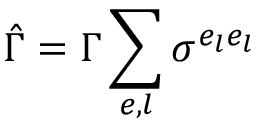<formula> <loc_0><loc_0><loc_500><loc_500>\hat { \Gamma } = \Gamma \sum _ { e , l } \sigma ^ { e _ { l } e _ { l } }</formula> 